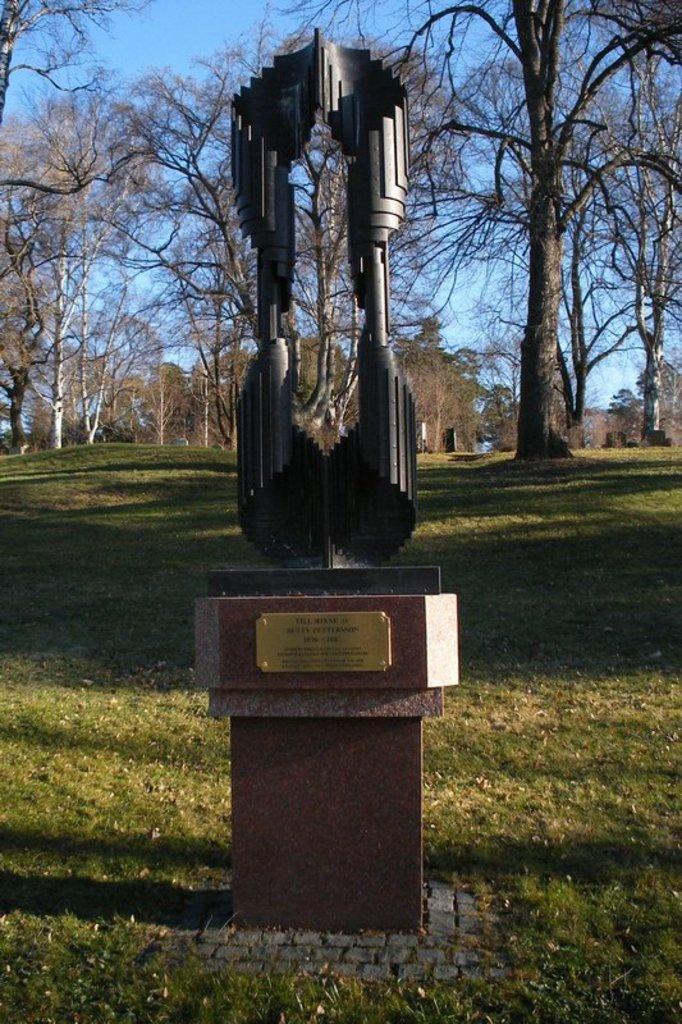Could you give a brief overview of what you see in this image? In this picture I can see a statue on the pedestal, and in the background there are trees and the sky. 